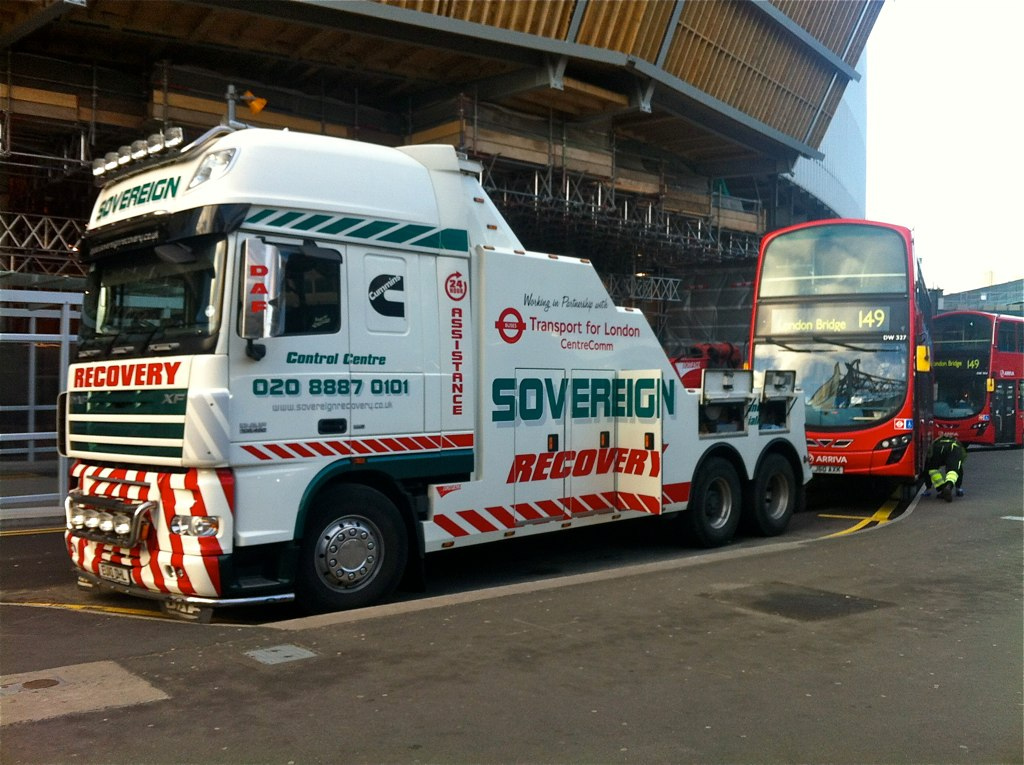Can you describe the main functions of this type of truck? This is a recovery tow truck, which is used to transport vehicles that have broken down or been involved in an accident. It's equipped with a flatbed on the rear and a winch to help in loading vehicles onto the truck bed for safe transportation. 